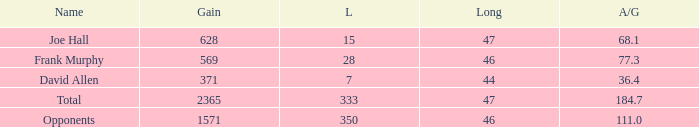Which Avg/G is the lowest one that has a Long smaller than 47, and a Name of frank murphy, and a Gain smaller than 569? None. 